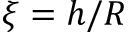<formula> <loc_0><loc_0><loc_500><loc_500>\xi = h / R</formula> 